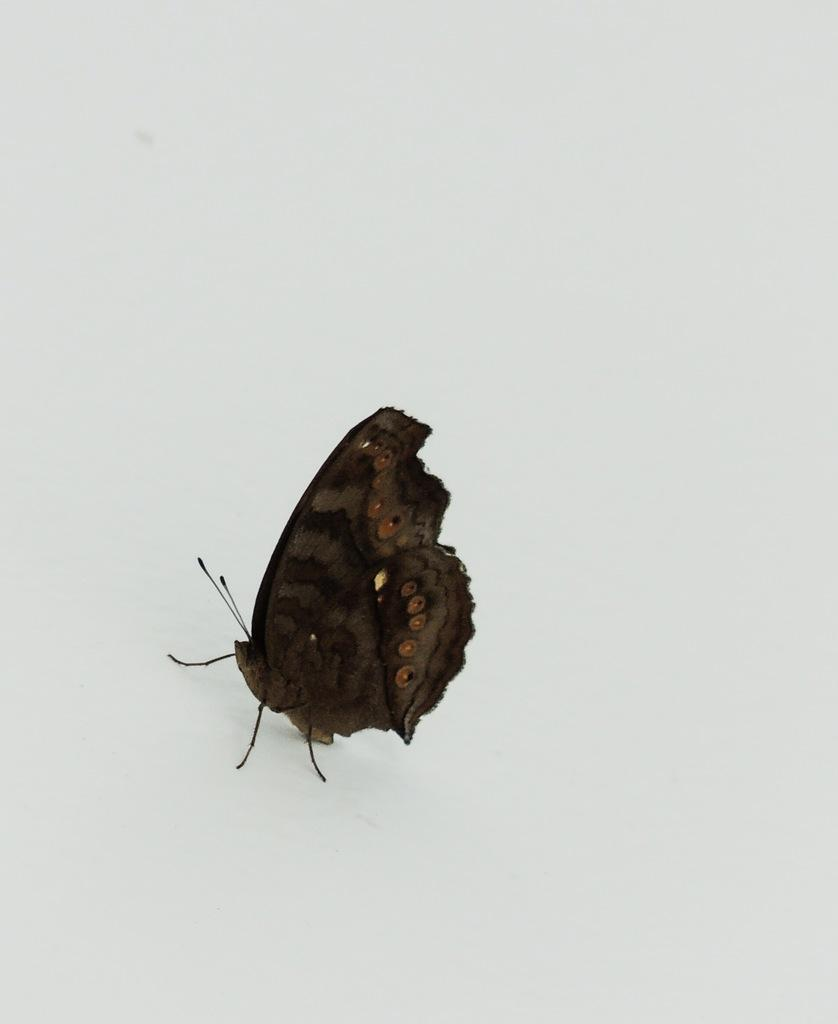What type of insect is in the image? There is a brown-colored butterfly in the image. Where is the butterfly located in the image? The butterfly is in the front of the image. What color can be seen in the background of the image? There is white color visible in the background of the image. What time of day is the hen shown in the image? There is no hen present in the image, so it is not possible to determine the time of day. 